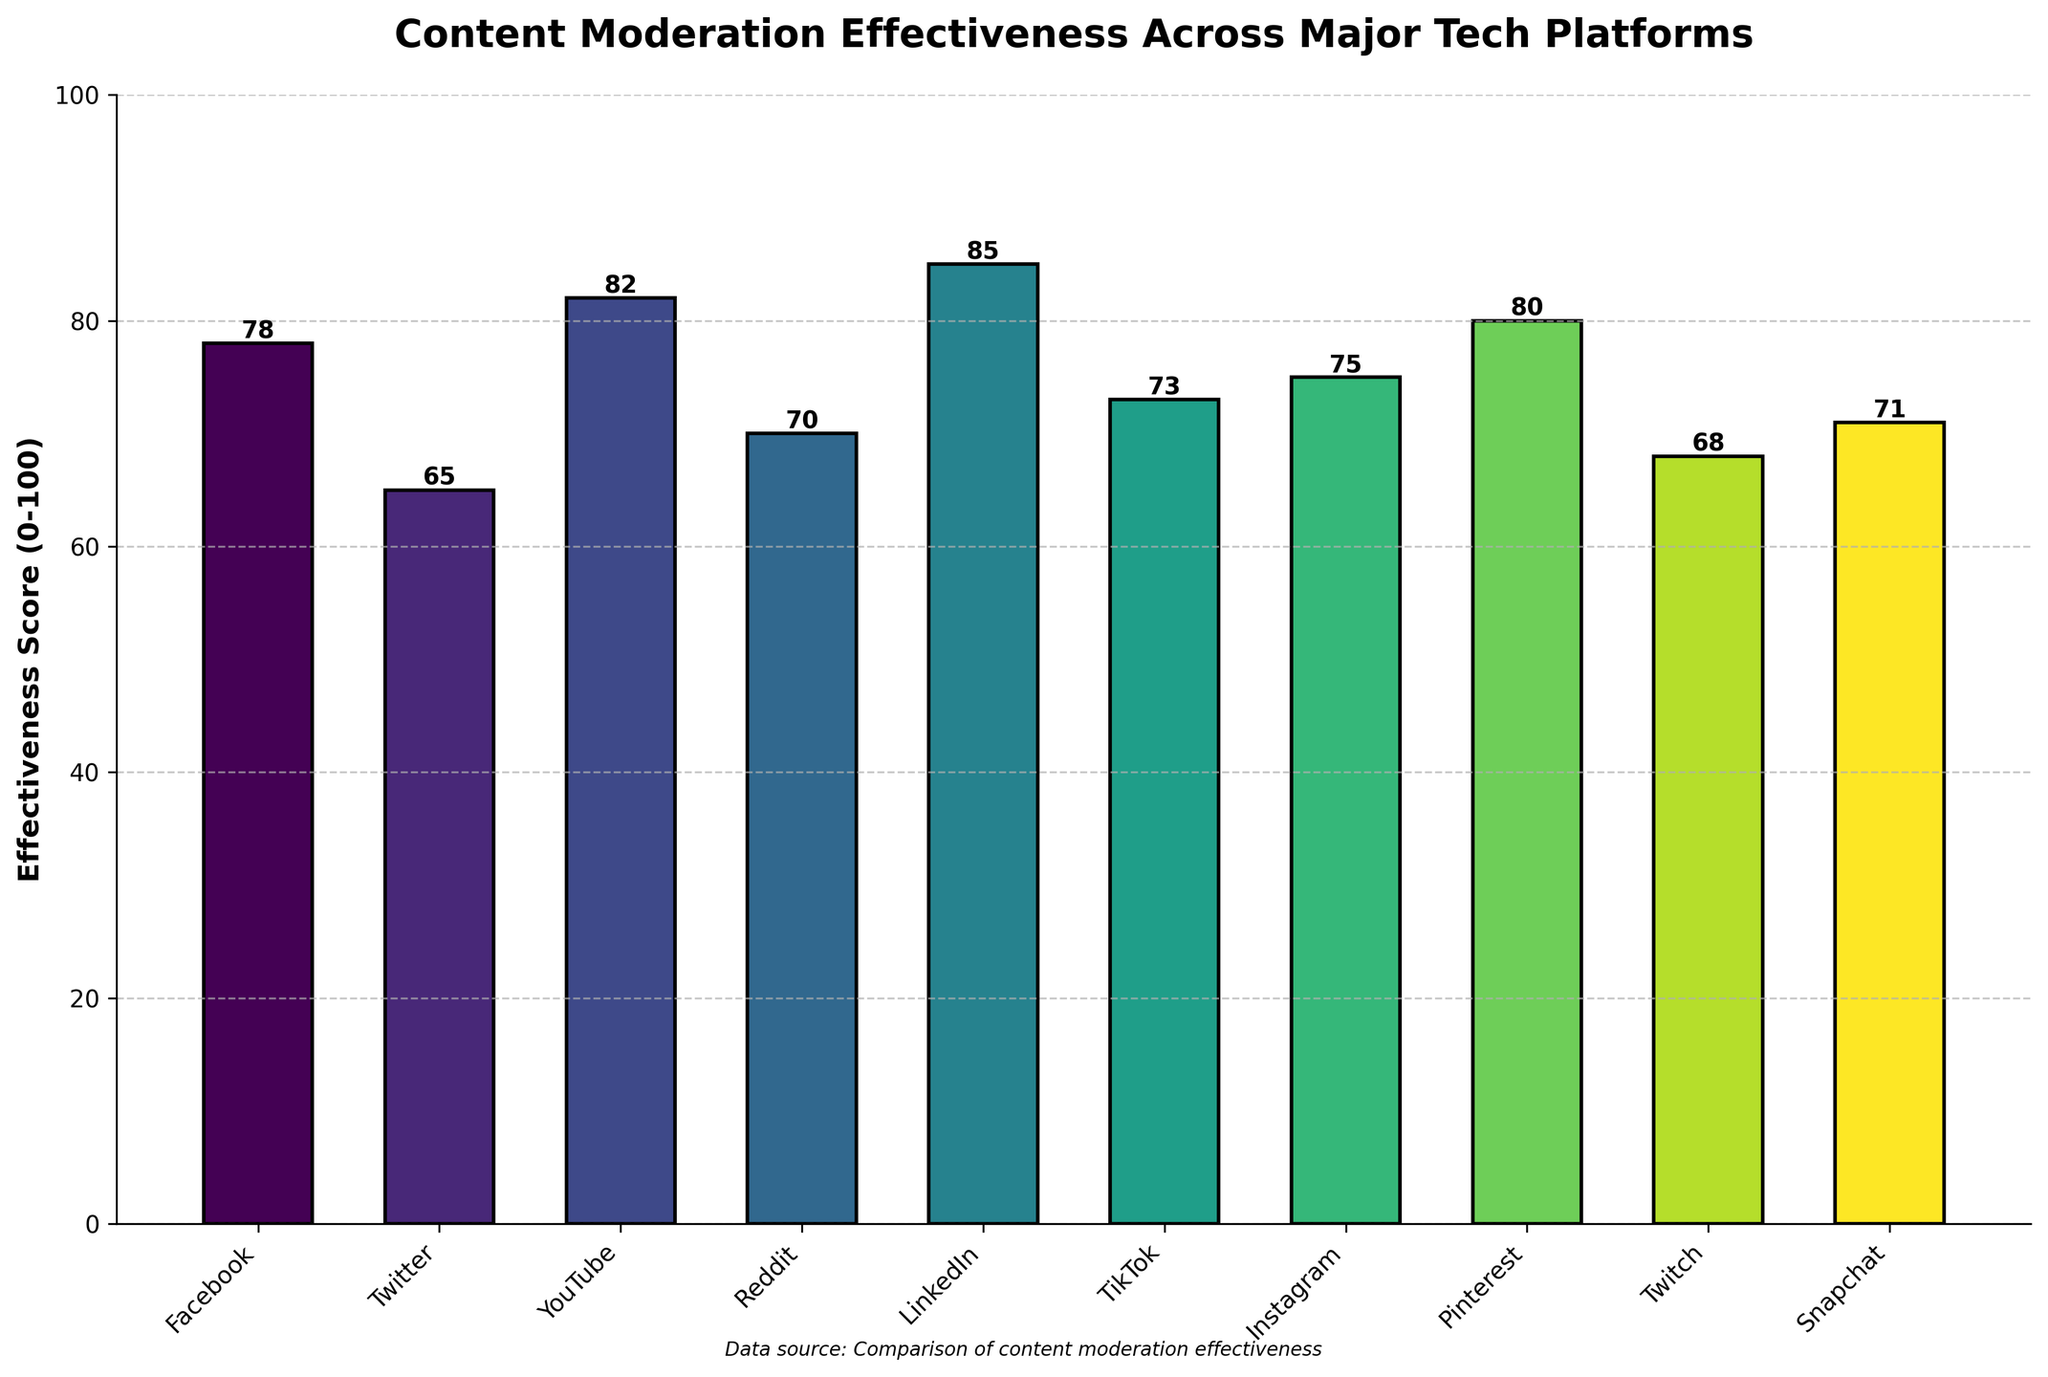What platform has the highest content moderation effectiveness score? By observing the height of the bars in the chart, the tallest bar corresponds to LinkedIn, which has the highest effectiveness score.
Answer: LinkedIn What is the difference in content moderation effectiveness scores between LinkedIn and Twitter? LinkedIn has an effectiveness score of 85, while Twitter has 65. Subtracting these two values gives the difference: 85 - 65 = 20.
Answer: 20 Which platform has a higher content moderation effectiveness score: Facebook or Instagram? By comparing the heights of the bars, Facebook has a score of 78 and Instagram has 75. Since 78 is greater than 75, Facebook has a higher score.
Answer: Facebook What is the average content moderation effectiveness score across all platforms? Sum the effectiveness scores of all platforms (78 + 65 + 82 + 70 + 85 + 73 + 75 + 80 + 68 + 71 = 747) and divide by the number of platforms (10): 747 / 10 = 74.7.
Answer: 74.7 How many platforms have an effectiveness score of 80 or above? By counting the bars that are at 80 or higher, we have YouTube (82), LinkedIn (85), and Pinterest (80). Therefore, there are three platforms.
Answer: 3 Which platforms have a content moderation effectiveness score below the average? The average score is 74.7. By observing the bars, the platforms below this value are Twitter (65), Reddit (70), Twitch (68), and Snapchat (71).
Answer: Twitter, Reddit, Twitch, Snapchat What is the median content moderation effectiveness score of the platforms? To find the median, first list the scores in ascending order: 65, 68, 70, 71, 73, 75, 78, 80, 82, 85. The median is the average of the middle two numbers (73 and 75): (73 + 75) / 2 = 74.
Answer: 74 Which has a greater spread in scores: effectiveness scores or user satisfaction percentages? To find the spread, calculate the range for both. Effectiveness score range: 85 - 65 = 20, User satisfaction range: 83 - 68 = 15. The spread is greater for effectiveness scores.
Answer: Effectiveness scores Which platform is closest to the median score of 74? By looking at the effectiveness scores, TikTok has a score of 73 and Instagram has a score of 75. Both are one point away from 74, but TikTok’s 73 is the closest value below the median.
Answer: TikTok What is the sum of the effectiveness scores for YouTube, Pinterest, and Snapchat? The effectiveness scores for YouTube, Pinterest, and Snapchat are 82, 80, and 71, respectively. Adding them together: 82 + 80 + 71 = 233.
Answer: 233 